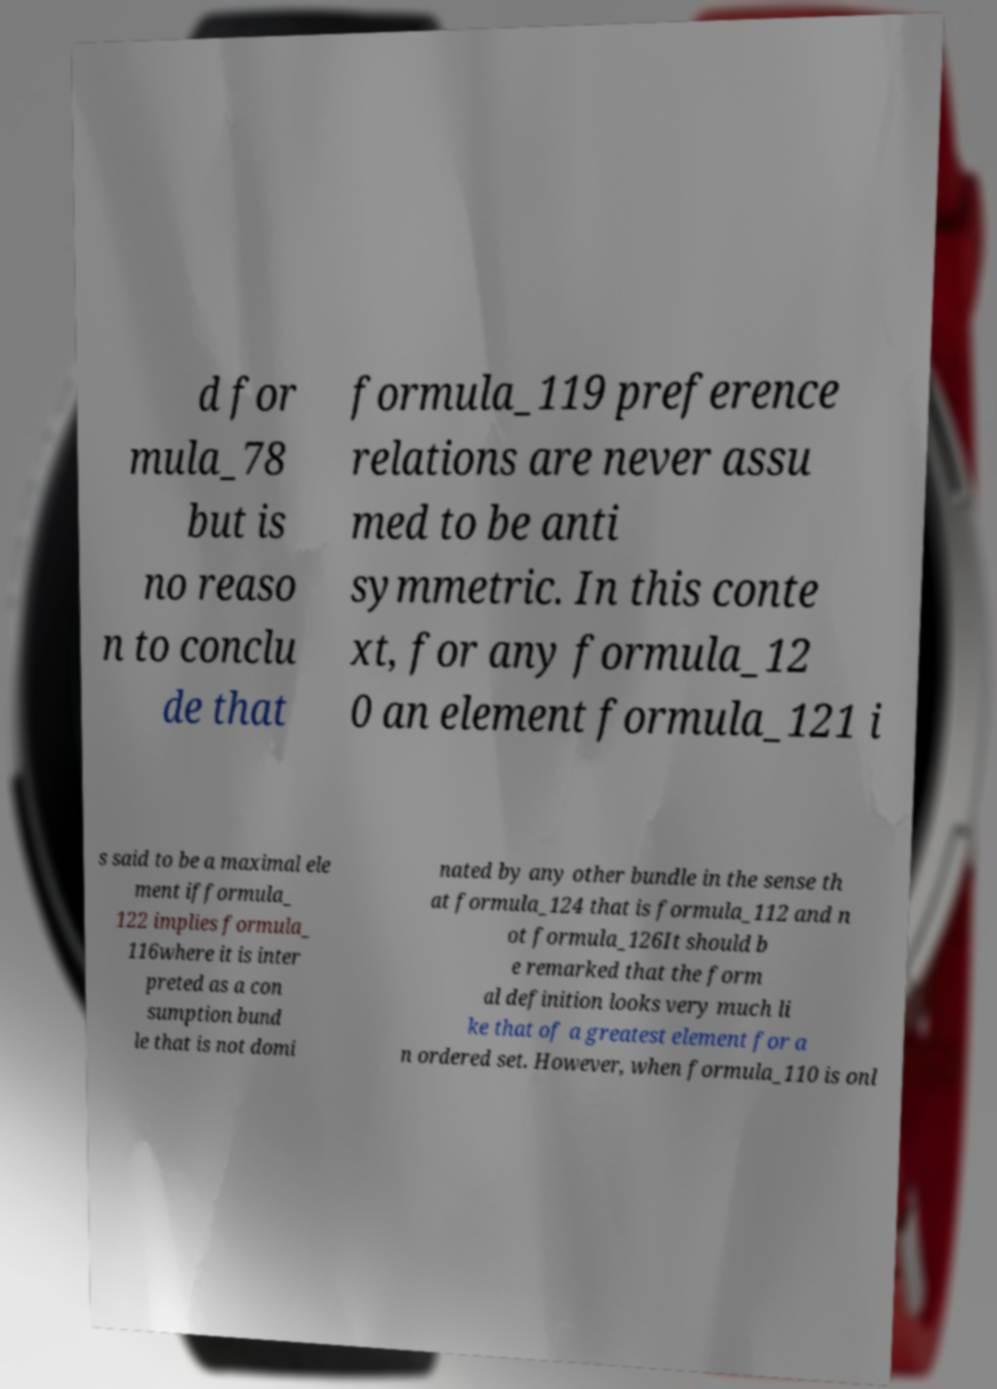For documentation purposes, I need the text within this image transcribed. Could you provide that? d for mula_78 but is no reaso n to conclu de that formula_119 preference relations are never assu med to be anti symmetric. In this conte xt, for any formula_12 0 an element formula_121 i s said to be a maximal ele ment ifformula_ 122 implies formula_ 116where it is inter preted as a con sumption bund le that is not domi nated by any other bundle in the sense th at formula_124 that is formula_112 and n ot formula_126It should b e remarked that the form al definition looks very much li ke that of a greatest element for a n ordered set. However, when formula_110 is onl 